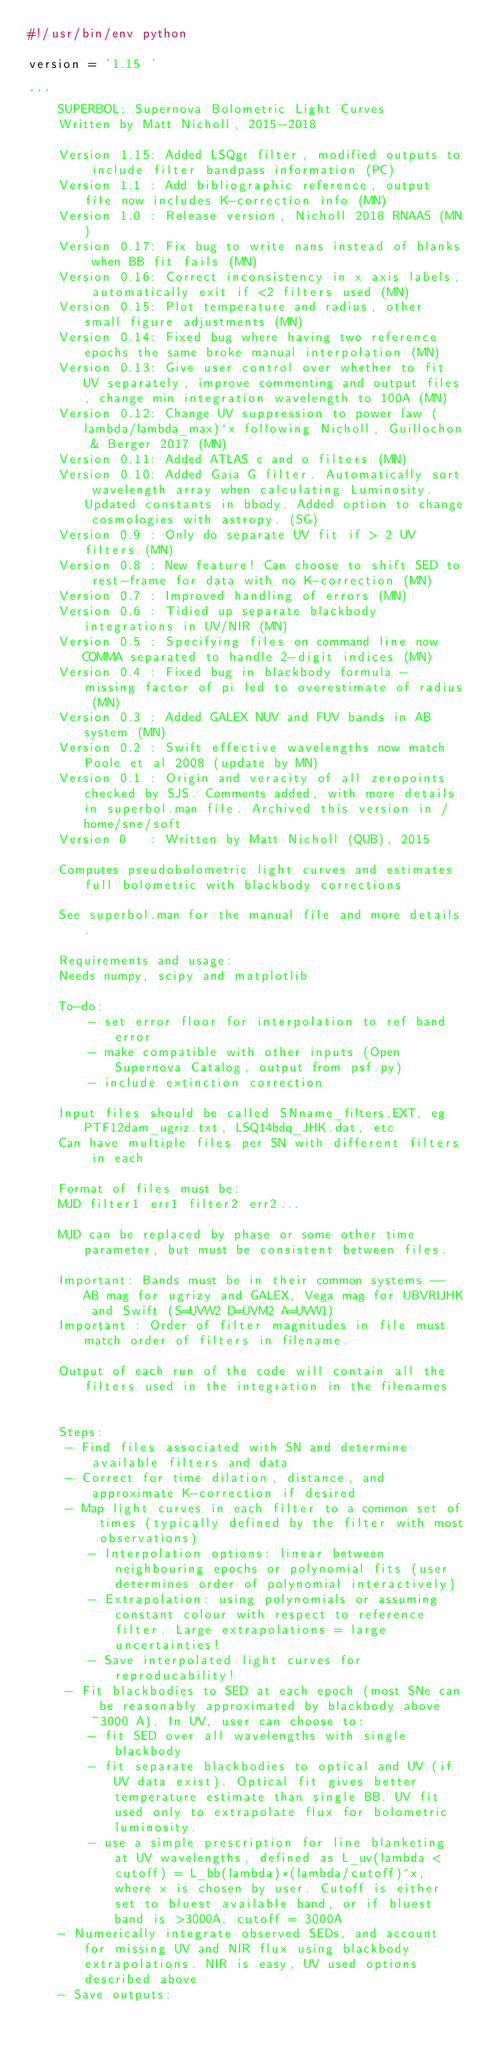<code> <loc_0><loc_0><loc_500><loc_500><_Python_>#!/usr/bin/env python

version = '1.15 '

'''
    SUPERBOL: Supernova Bolometric Light Curves
    Written by Matt Nicholl, 2015-2018
    
    Version 1.15: Added LSQgr filter, modified outputs to include filter bandpass information (PC)
    Version 1.1 : Add bibliographic reference, output file now includes K-correction info (MN)
    Version 1.0 : Release version, Nicholl 2018 RNAAS (MN)
    Version 0.17: Fix bug to write nans instead of blanks when BB fit fails (MN)
    Version 0.16: Correct inconsistency in x axis labels, automatically exit if <2 filters used (MN)
    Version 0.15: Plot temperature and radius, other small figure adjustments (MN)
    Version 0.14: Fixed bug where having two reference epochs the same broke manual interpolation (MN)
    Version 0.13: Give user control over whether to fit UV separately, improve commenting and output files, change min integration wavelength to 100A (MN)
    Version 0.12: Change UV suppression to power law (lambda/lambda_max)^x following Nicholl, Guillochon & Berger 2017 (MN)
    Version 0.11: Added ATLAS c and o filters (MN)
    Version 0.10: Added Gaia G filter. Automatically sort wavelength array when calculating Luminosity. Updated constants in bbody. Added option to change cosmologies with astropy. (SG)
    Version 0.9 : Only do separate UV fit if > 2 UV filters (MN)
    Version 0.8 : New feature! Can choose to shift SED to rest-frame for data with no K-correction (MN)
    Version 0.7 : Improved handling of errors (MN)
    Version 0.6 : Tidied up separate blackbody integrations in UV/NIR (MN)
    Version 0.5 : Specifying files on command line now COMMA separated to handle 2-digit indices (MN)
    Version 0.4 : Fixed bug in blackbody formula - missing factor of pi led to overestimate of radius (MN)
    Version 0.3 : Added GALEX NUV and FUV bands in AB system (MN)
    Version 0.2 : Swift effective wavelengths now match Poole et al 2008 (update by MN)
    Version 0.1 : Origin and veracity of all zeropoints checked by SJS. Comments added, with more details in superbol.man file. Archived this version in /home/sne/soft
    Version 0   : Written by Matt Nicholl (QUB), 2015

    Computes pseudobolometric light curves and estimates full bolometric with blackbody corrections

    See superbol.man for the manual file and more details.

    Requirements and usage:
    Needs numpy, scipy and matplotlib

    To-do:
        - set error floor for interpolation to ref band error
        - make compatible with other inputs (Open Supernova Catalog, output from psf.py)
        - include extinction correction

    Input files should be called SNname_filters.EXT, eg PTF12dam_ugriz.txt, LSQ14bdq_JHK.dat, etc
    Can have multiple files per SN with different filters in each

    Format of files must be:
    MJD filter1 err1 filter2 err2...

    MJD can be replaced by phase or some other time parameter, but must be consistent between files.

    Important: Bands must be in their common systems -- AB mag for ugrizy and GALEX, Vega mag for UBVRIJHK and Swift (S=UVW2 D=UVM2 A=UVW1)
    Important : Order of filter magnitudes in file must match order of filters in filename.

    Output of each run of the code will contain all the filters used in the integration in the filenames


    Steps:
     - Find files associated with SN and determine available filters and data
     - Correct for time dilation, distance, and approximate K-correction if desired
     - Map light curves in each filter to a common set of times (typically defined by the filter with most observations)
        - Interpolation options: linear between neighbouring epochs or polynomial fits (user determines order of polynomial interactively)
        - Extrapolation: using polynomials or assuming constant colour with respect to reference filter. Large extrapolations = large uncertainties!
        - Save interpolated light curves for reproducability!
     - Fit blackbodies to SED at each epoch (most SNe can be reasonably approximated by blackbody above ~3000 A). In UV, user can choose to:
        - fit SED over all wavelengths with single blackbody
        - fit separate blackbodies to optical and UV (if UV data exist). Optical fit gives better temperature estimate than single BB. UV fit used only to extrapolate flux for bolometric luminosity.
        - use a simple prescription for line blanketing at UV wavelengths, defined as L_uv(lambda < cutoff) = L_bb(lambda)*(lambda/cutoff)^x, where x is chosen by user. Cutoff is either set to bluest available band, or if bluest band is >3000A, cutoff = 3000A
    - Numerically integrate observed SEDs, and account for missing UV and NIR flux using blackbody extrapolations. NIR is easy, UV used options described above
    - Save outputs:</code> 